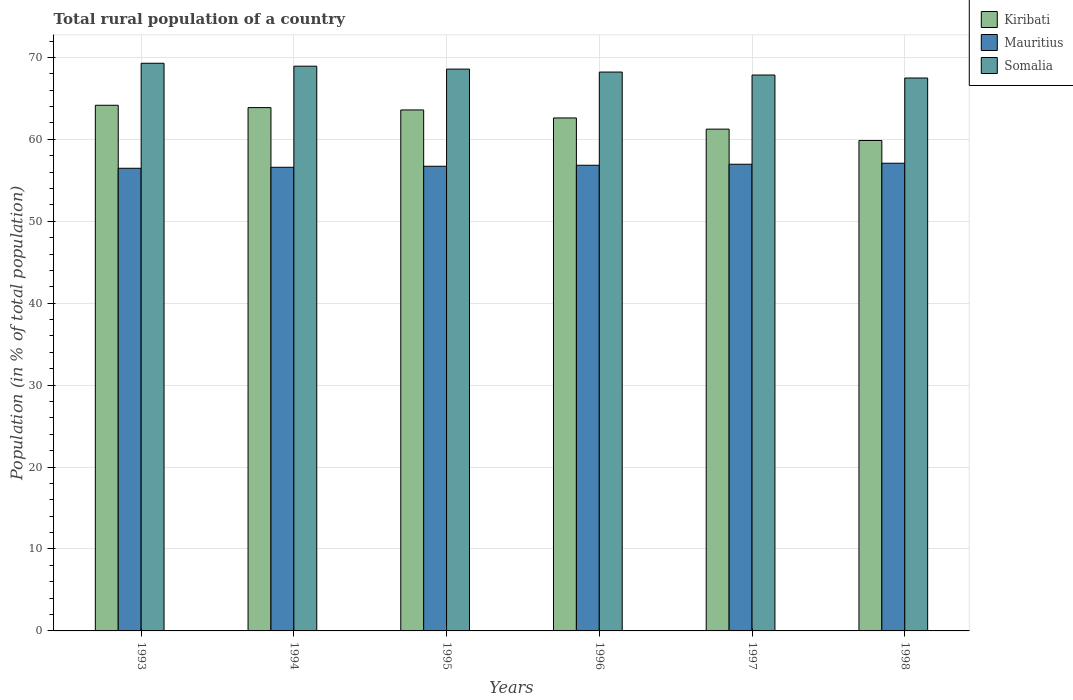How many groups of bars are there?
Provide a succinct answer. 6. Are the number of bars on each tick of the X-axis equal?
Ensure brevity in your answer.  Yes. What is the rural population in Mauritius in 1995?
Your answer should be compact. 56.72. Across all years, what is the maximum rural population in Mauritius?
Provide a short and direct response. 57.08. Across all years, what is the minimum rural population in Somalia?
Ensure brevity in your answer.  67.49. In which year was the rural population in Somalia maximum?
Give a very brief answer. 1993. What is the total rural population in Somalia in the graph?
Your response must be concise. 410.35. What is the difference between the rural population in Mauritius in 1994 and that in 1996?
Your answer should be compact. -0.25. What is the difference between the rural population in Somalia in 1993 and the rural population in Mauritius in 1998?
Offer a very short reply. 12.2. What is the average rural population in Kiribati per year?
Keep it short and to the point. 62.56. In the year 1998, what is the difference between the rural population in Kiribati and rural population in Somalia?
Offer a very short reply. -7.63. What is the ratio of the rural population in Mauritius in 1995 to that in 1997?
Your answer should be compact. 1. Is the rural population in Mauritius in 1993 less than that in 1994?
Offer a terse response. Yes. Is the difference between the rural population in Kiribati in 1994 and 1995 greater than the difference between the rural population in Somalia in 1994 and 1995?
Provide a succinct answer. No. What is the difference between the highest and the second highest rural population in Kiribati?
Your answer should be compact. 0.28. What is the difference between the highest and the lowest rural population in Mauritius?
Offer a very short reply. 0.61. Is the sum of the rural population in Kiribati in 1994 and 1996 greater than the maximum rural population in Somalia across all years?
Ensure brevity in your answer.  Yes. What does the 1st bar from the left in 1993 represents?
Provide a short and direct response. Kiribati. What does the 3rd bar from the right in 1995 represents?
Your response must be concise. Kiribati. Is it the case that in every year, the sum of the rural population in Kiribati and rural population in Somalia is greater than the rural population in Mauritius?
Offer a very short reply. Yes. Are all the bars in the graph horizontal?
Provide a short and direct response. No. How many years are there in the graph?
Ensure brevity in your answer.  6. What is the difference between two consecutive major ticks on the Y-axis?
Provide a succinct answer. 10. Does the graph contain any zero values?
Your answer should be compact. No. Where does the legend appear in the graph?
Ensure brevity in your answer.  Top right. How many legend labels are there?
Offer a terse response. 3. How are the legend labels stacked?
Keep it short and to the point. Vertical. What is the title of the graph?
Your response must be concise. Total rural population of a country. Does "Seychelles" appear as one of the legend labels in the graph?
Your answer should be very brief. No. What is the label or title of the Y-axis?
Provide a succinct answer. Population (in % of total population). What is the Population (in % of total population) of Kiribati in 1993?
Make the answer very short. 64.16. What is the Population (in % of total population) of Mauritius in 1993?
Make the answer very short. 56.47. What is the Population (in % of total population) of Somalia in 1993?
Make the answer very short. 69.29. What is the Population (in % of total population) of Kiribati in 1994?
Keep it short and to the point. 63.88. What is the Population (in % of total population) of Mauritius in 1994?
Make the answer very short. 56.59. What is the Population (in % of total population) of Somalia in 1994?
Provide a succinct answer. 68.93. What is the Population (in % of total population) of Kiribati in 1995?
Ensure brevity in your answer.  63.59. What is the Population (in % of total population) in Mauritius in 1995?
Offer a very short reply. 56.72. What is the Population (in % of total population) in Somalia in 1995?
Your answer should be compact. 68.58. What is the Population (in % of total population) of Kiribati in 1996?
Provide a short and direct response. 62.61. What is the Population (in % of total population) of Mauritius in 1996?
Make the answer very short. 56.84. What is the Population (in % of total population) in Somalia in 1996?
Offer a terse response. 68.22. What is the Population (in % of total population) in Kiribati in 1997?
Your response must be concise. 61.25. What is the Population (in % of total population) of Mauritius in 1997?
Give a very brief answer. 56.96. What is the Population (in % of total population) of Somalia in 1997?
Your answer should be compact. 67.85. What is the Population (in % of total population) of Kiribati in 1998?
Provide a succinct answer. 59.86. What is the Population (in % of total population) in Mauritius in 1998?
Your answer should be compact. 57.08. What is the Population (in % of total population) in Somalia in 1998?
Your response must be concise. 67.49. Across all years, what is the maximum Population (in % of total population) of Kiribati?
Offer a terse response. 64.16. Across all years, what is the maximum Population (in % of total population) of Mauritius?
Your response must be concise. 57.08. Across all years, what is the maximum Population (in % of total population) of Somalia?
Make the answer very short. 69.29. Across all years, what is the minimum Population (in % of total population) in Kiribati?
Keep it short and to the point. 59.86. Across all years, what is the minimum Population (in % of total population) in Mauritius?
Your answer should be very brief. 56.47. Across all years, what is the minimum Population (in % of total population) in Somalia?
Your answer should be very brief. 67.49. What is the total Population (in % of total population) of Kiribati in the graph?
Provide a succinct answer. 375.35. What is the total Population (in % of total population) of Mauritius in the graph?
Provide a succinct answer. 340.66. What is the total Population (in % of total population) in Somalia in the graph?
Offer a terse response. 410.35. What is the difference between the Population (in % of total population) of Kiribati in 1993 and that in 1994?
Ensure brevity in your answer.  0.28. What is the difference between the Population (in % of total population) in Mauritius in 1993 and that in 1994?
Ensure brevity in your answer.  -0.12. What is the difference between the Population (in % of total population) of Somalia in 1993 and that in 1994?
Provide a succinct answer. 0.36. What is the difference between the Population (in % of total population) in Kiribati in 1993 and that in 1995?
Your answer should be very brief. 0.57. What is the difference between the Population (in % of total population) of Mauritius in 1993 and that in 1995?
Offer a very short reply. -0.25. What is the difference between the Population (in % of total population) of Somalia in 1993 and that in 1995?
Make the answer very short. 0.71. What is the difference between the Population (in % of total population) in Kiribati in 1993 and that in 1996?
Ensure brevity in your answer.  1.55. What is the difference between the Population (in % of total population) in Mauritius in 1993 and that in 1996?
Your answer should be very brief. -0.37. What is the difference between the Population (in % of total population) of Somalia in 1993 and that in 1996?
Keep it short and to the point. 1.07. What is the difference between the Population (in % of total population) of Kiribati in 1993 and that in 1997?
Provide a succinct answer. 2.91. What is the difference between the Population (in % of total population) of Mauritius in 1993 and that in 1997?
Provide a succinct answer. -0.49. What is the difference between the Population (in % of total population) in Somalia in 1993 and that in 1997?
Provide a short and direct response. 1.44. What is the difference between the Population (in % of total population) in Kiribati in 1993 and that in 1998?
Ensure brevity in your answer.  4.3. What is the difference between the Population (in % of total population) in Mauritius in 1993 and that in 1998?
Your answer should be compact. -0.61. What is the difference between the Population (in % of total population) in Kiribati in 1994 and that in 1995?
Your response must be concise. 0.29. What is the difference between the Population (in % of total population) in Mauritius in 1994 and that in 1995?
Your answer should be very brief. -0.12. What is the difference between the Population (in % of total population) in Somalia in 1994 and that in 1995?
Make the answer very short. 0.36. What is the difference between the Population (in % of total population) of Kiribati in 1994 and that in 1996?
Give a very brief answer. 1.26. What is the difference between the Population (in % of total population) of Mauritius in 1994 and that in 1996?
Keep it short and to the point. -0.25. What is the difference between the Population (in % of total population) in Somalia in 1994 and that in 1996?
Offer a very short reply. 0.72. What is the difference between the Population (in % of total population) of Kiribati in 1994 and that in 1997?
Your answer should be very brief. 2.63. What is the difference between the Population (in % of total population) in Mauritius in 1994 and that in 1997?
Your response must be concise. -0.37. What is the difference between the Population (in % of total population) in Kiribati in 1994 and that in 1998?
Provide a short and direct response. 4.01. What is the difference between the Population (in % of total population) of Mauritius in 1994 and that in 1998?
Keep it short and to the point. -0.49. What is the difference between the Population (in % of total population) of Somalia in 1994 and that in 1998?
Offer a terse response. 1.44. What is the difference between the Population (in % of total population) of Kiribati in 1995 and that in 1996?
Keep it short and to the point. 0.98. What is the difference between the Population (in % of total population) in Mauritius in 1995 and that in 1996?
Ensure brevity in your answer.  -0.12. What is the difference between the Population (in % of total population) of Somalia in 1995 and that in 1996?
Provide a succinct answer. 0.36. What is the difference between the Population (in % of total population) in Kiribati in 1995 and that in 1997?
Ensure brevity in your answer.  2.34. What is the difference between the Population (in % of total population) of Mauritius in 1995 and that in 1997?
Offer a terse response. -0.25. What is the difference between the Population (in % of total population) of Somalia in 1995 and that in 1997?
Offer a terse response. 0.72. What is the difference between the Population (in % of total population) in Kiribati in 1995 and that in 1998?
Your answer should be compact. 3.73. What is the difference between the Population (in % of total population) of Mauritius in 1995 and that in 1998?
Make the answer very short. -0.37. What is the difference between the Population (in % of total population) of Somalia in 1995 and that in 1998?
Keep it short and to the point. 1.09. What is the difference between the Population (in % of total population) of Kiribati in 1996 and that in 1997?
Your response must be concise. 1.37. What is the difference between the Population (in % of total population) in Mauritius in 1996 and that in 1997?
Offer a terse response. -0.12. What is the difference between the Population (in % of total population) of Somalia in 1996 and that in 1997?
Keep it short and to the point. 0.36. What is the difference between the Population (in % of total population) of Kiribati in 1996 and that in 1998?
Your answer should be compact. 2.75. What is the difference between the Population (in % of total population) of Mauritius in 1996 and that in 1998?
Give a very brief answer. -0.24. What is the difference between the Population (in % of total population) of Somalia in 1996 and that in 1998?
Offer a terse response. 0.73. What is the difference between the Population (in % of total population) of Kiribati in 1997 and that in 1998?
Ensure brevity in your answer.  1.39. What is the difference between the Population (in % of total population) in Mauritius in 1997 and that in 1998?
Give a very brief answer. -0.12. What is the difference between the Population (in % of total population) of Somalia in 1997 and that in 1998?
Make the answer very short. 0.36. What is the difference between the Population (in % of total population) in Kiribati in 1993 and the Population (in % of total population) in Mauritius in 1994?
Your answer should be compact. 7.57. What is the difference between the Population (in % of total population) of Kiribati in 1993 and the Population (in % of total population) of Somalia in 1994?
Offer a very short reply. -4.77. What is the difference between the Population (in % of total population) in Mauritius in 1993 and the Population (in % of total population) in Somalia in 1994?
Keep it short and to the point. -12.46. What is the difference between the Population (in % of total population) in Kiribati in 1993 and the Population (in % of total population) in Mauritius in 1995?
Make the answer very short. 7.45. What is the difference between the Population (in % of total population) in Kiribati in 1993 and the Population (in % of total population) in Somalia in 1995?
Your response must be concise. -4.41. What is the difference between the Population (in % of total population) of Mauritius in 1993 and the Population (in % of total population) of Somalia in 1995?
Offer a very short reply. -12.11. What is the difference between the Population (in % of total population) of Kiribati in 1993 and the Population (in % of total population) of Mauritius in 1996?
Provide a succinct answer. 7.32. What is the difference between the Population (in % of total population) in Kiribati in 1993 and the Population (in % of total population) in Somalia in 1996?
Provide a succinct answer. -4.05. What is the difference between the Population (in % of total population) in Mauritius in 1993 and the Population (in % of total population) in Somalia in 1996?
Provide a short and direct response. -11.74. What is the difference between the Population (in % of total population) of Kiribati in 1993 and the Population (in % of total population) of Mauritius in 1997?
Offer a very short reply. 7.2. What is the difference between the Population (in % of total population) in Kiribati in 1993 and the Population (in % of total population) in Somalia in 1997?
Offer a very short reply. -3.69. What is the difference between the Population (in % of total population) in Mauritius in 1993 and the Population (in % of total population) in Somalia in 1997?
Your answer should be very brief. -11.38. What is the difference between the Population (in % of total population) in Kiribati in 1993 and the Population (in % of total population) in Mauritius in 1998?
Make the answer very short. 7.08. What is the difference between the Population (in % of total population) in Kiribati in 1993 and the Population (in % of total population) in Somalia in 1998?
Offer a very short reply. -3.33. What is the difference between the Population (in % of total population) in Mauritius in 1993 and the Population (in % of total population) in Somalia in 1998?
Offer a very short reply. -11.02. What is the difference between the Population (in % of total population) of Kiribati in 1994 and the Population (in % of total population) of Mauritius in 1995?
Make the answer very short. 7.16. What is the difference between the Population (in % of total population) of Kiribati in 1994 and the Population (in % of total population) of Somalia in 1995?
Offer a terse response. -4.7. What is the difference between the Population (in % of total population) in Mauritius in 1994 and the Population (in % of total population) in Somalia in 1995?
Give a very brief answer. -11.98. What is the difference between the Population (in % of total population) in Kiribati in 1994 and the Population (in % of total population) in Mauritius in 1996?
Provide a succinct answer. 7.04. What is the difference between the Population (in % of total population) of Kiribati in 1994 and the Population (in % of total population) of Somalia in 1996?
Make the answer very short. -4.34. What is the difference between the Population (in % of total population) in Mauritius in 1994 and the Population (in % of total population) in Somalia in 1996?
Provide a short and direct response. -11.62. What is the difference between the Population (in % of total population) in Kiribati in 1994 and the Population (in % of total population) in Mauritius in 1997?
Ensure brevity in your answer.  6.92. What is the difference between the Population (in % of total population) in Kiribati in 1994 and the Population (in % of total population) in Somalia in 1997?
Your answer should be very brief. -3.98. What is the difference between the Population (in % of total population) in Mauritius in 1994 and the Population (in % of total population) in Somalia in 1997?
Ensure brevity in your answer.  -11.26. What is the difference between the Population (in % of total population) of Kiribati in 1994 and the Population (in % of total population) of Mauritius in 1998?
Give a very brief answer. 6.79. What is the difference between the Population (in % of total population) of Kiribati in 1994 and the Population (in % of total population) of Somalia in 1998?
Offer a terse response. -3.61. What is the difference between the Population (in % of total population) of Mauritius in 1994 and the Population (in % of total population) of Somalia in 1998?
Your response must be concise. -10.9. What is the difference between the Population (in % of total population) in Kiribati in 1995 and the Population (in % of total population) in Mauritius in 1996?
Your answer should be compact. 6.75. What is the difference between the Population (in % of total population) in Kiribati in 1995 and the Population (in % of total population) in Somalia in 1996?
Your response must be concise. -4.62. What is the difference between the Population (in % of total population) in Mauritius in 1995 and the Population (in % of total population) in Somalia in 1996?
Provide a succinct answer. -11.5. What is the difference between the Population (in % of total population) in Kiribati in 1995 and the Population (in % of total population) in Mauritius in 1997?
Make the answer very short. 6.63. What is the difference between the Population (in % of total population) in Kiribati in 1995 and the Population (in % of total population) in Somalia in 1997?
Offer a very short reply. -4.26. What is the difference between the Population (in % of total population) of Mauritius in 1995 and the Population (in % of total population) of Somalia in 1997?
Keep it short and to the point. -11.14. What is the difference between the Population (in % of total population) of Kiribati in 1995 and the Population (in % of total population) of Mauritius in 1998?
Your answer should be very brief. 6.51. What is the difference between the Population (in % of total population) in Kiribati in 1995 and the Population (in % of total population) in Somalia in 1998?
Your answer should be very brief. -3.9. What is the difference between the Population (in % of total population) in Mauritius in 1995 and the Population (in % of total population) in Somalia in 1998?
Make the answer very short. -10.77. What is the difference between the Population (in % of total population) of Kiribati in 1996 and the Population (in % of total population) of Mauritius in 1997?
Provide a succinct answer. 5.65. What is the difference between the Population (in % of total population) of Kiribati in 1996 and the Population (in % of total population) of Somalia in 1997?
Provide a succinct answer. -5.24. What is the difference between the Population (in % of total population) of Mauritius in 1996 and the Population (in % of total population) of Somalia in 1997?
Provide a succinct answer. -11.01. What is the difference between the Population (in % of total population) of Kiribati in 1996 and the Population (in % of total population) of Mauritius in 1998?
Make the answer very short. 5.53. What is the difference between the Population (in % of total population) in Kiribati in 1996 and the Population (in % of total population) in Somalia in 1998?
Offer a very short reply. -4.88. What is the difference between the Population (in % of total population) in Mauritius in 1996 and the Population (in % of total population) in Somalia in 1998?
Your answer should be compact. -10.65. What is the difference between the Population (in % of total population) of Kiribati in 1997 and the Population (in % of total population) of Mauritius in 1998?
Provide a short and direct response. 4.16. What is the difference between the Population (in % of total population) of Kiribati in 1997 and the Population (in % of total population) of Somalia in 1998?
Offer a very short reply. -6.24. What is the difference between the Population (in % of total population) of Mauritius in 1997 and the Population (in % of total population) of Somalia in 1998?
Your answer should be very brief. -10.53. What is the average Population (in % of total population) of Kiribati per year?
Make the answer very short. 62.56. What is the average Population (in % of total population) in Mauritius per year?
Ensure brevity in your answer.  56.78. What is the average Population (in % of total population) in Somalia per year?
Ensure brevity in your answer.  68.39. In the year 1993, what is the difference between the Population (in % of total population) of Kiribati and Population (in % of total population) of Mauritius?
Ensure brevity in your answer.  7.69. In the year 1993, what is the difference between the Population (in % of total population) of Kiribati and Population (in % of total population) of Somalia?
Keep it short and to the point. -5.13. In the year 1993, what is the difference between the Population (in % of total population) of Mauritius and Population (in % of total population) of Somalia?
Your answer should be very brief. -12.82. In the year 1994, what is the difference between the Population (in % of total population) in Kiribati and Population (in % of total population) in Mauritius?
Keep it short and to the point. 7.28. In the year 1994, what is the difference between the Population (in % of total population) in Kiribati and Population (in % of total population) in Somalia?
Make the answer very short. -5.06. In the year 1994, what is the difference between the Population (in % of total population) in Mauritius and Population (in % of total population) in Somalia?
Your answer should be very brief. -12.34. In the year 1995, what is the difference between the Population (in % of total population) in Kiribati and Population (in % of total population) in Mauritius?
Offer a very short reply. 6.88. In the year 1995, what is the difference between the Population (in % of total population) in Kiribati and Population (in % of total population) in Somalia?
Offer a terse response. -4.98. In the year 1995, what is the difference between the Population (in % of total population) in Mauritius and Population (in % of total population) in Somalia?
Give a very brief answer. -11.86. In the year 1996, what is the difference between the Population (in % of total population) of Kiribati and Population (in % of total population) of Mauritius?
Your answer should be compact. 5.78. In the year 1996, what is the difference between the Population (in % of total population) in Kiribati and Population (in % of total population) in Somalia?
Make the answer very short. -5.6. In the year 1996, what is the difference between the Population (in % of total population) of Mauritius and Population (in % of total population) of Somalia?
Give a very brief answer. -11.38. In the year 1997, what is the difference between the Population (in % of total population) in Kiribati and Population (in % of total population) in Mauritius?
Offer a terse response. 4.29. In the year 1997, what is the difference between the Population (in % of total population) in Kiribati and Population (in % of total population) in Somalia?
Provide a short and direct response. -6.61. In the year 1997, what is the difference between the Population (in % of total population) of Mauritius and Population (in % of total population) of Somalia?
Offer a very short reply. -10.89. In the year 1998, what is the difference between the Population (in % of total population) in Kiribati and Population (in % of total population) in Mauritius?
Offer a very short reply. 2.78. In the year 1998, what is the difference between the Population (in % of total population) in Kiribati and Population (in % of total population) in Somalia?
Offer a very short reply. -7.63. In the year 1998, what is the difference between the Population (in % of total population) in Mauritius and Population (in % of total population) in Somalia?
Offer a very short reply. -10.4. What is the ratio of the Population (in % of total population) of Mauritius in 1993 to that in 1994?
Offer a very short reply. 1. What is the ratio of the Population (in % of total population) in Kiribati in 1993 to that in 1995?
Ensure brevity in your answer.  1.01. What is the ratio of the Population (in % of total population) of Somalia in 1993 to that in 1995?
Your response must be concise. 1.01. What is the ratio of the Population (in % of total population) in Kiribati in 1993 to that in 1996?
Your answer should be compact. 1.02. What is the ratio of the Population (in % of total population) of Mauritius in 1993 to that in 1996?
Your answer should be very brief. 0.99. What is the ratio of the Population (in % of total population) of Somalia in 1993 to that in 1996?
Provide a short and direct response. 1.02. What is the ratio of the Population (in % of total population) of Kiribati in 1993 to that in 1997?
Ensure brevity in your answer.  1.05. What is the ratio of the Population (in % of total population) of Somalia in 1993 to that in 1997?
Offer a terse response. 1.02. What is the ratio of the Population (in % of total population) in Kiribati in 1993 to that in 1998?
Offer a terse response. 1.07. What is the ratio of the Population (in % of total population) in Somalia in 1993 to that in 1998?
Give a very brief answer. 1.03. What is the ratio of the Population (in % of total population) of Mauritius in 1994 to that in 1995?
Offer a terse response. 1. What is the ratio of the Population (in % of total population) of Somalia in 1994 to that in 1995?
Ensure brevity in your answer.  1.01. What is the ratio of the Population (in % of total population) of Kiribati in 1994 to that in 1996?
Offer a very short reply. 1.02. What is the ratio of the Population (in % of total population) of Somalia in 1994 to that in 1996?
Your answer should be very brief. 1.01. What is the ratio of the Population (in % of total population) of Kiribati in 1994 to that in 1997?
Make the answer very short. 1.04. What is the ratio of the Population (in % of total population) in Mauritius in 1994 to that in 1997?
Provide a succinct answer. 0.99. What is the ratio of the Population (in % of total population) of Somalia in 1994 to that in 1997?
Keep it short and to the point. 1.02. What is the ratio of the Population (in % of total population) in Kiribati in 1994 to that in 1998?
Your answer should be compact. 1.07. What is the ratio of the Population (in % of total population) of Somalia in 1994 to that in 1998?
Your answer should be compact. 1.02. What is the ratio of the Population (in % of total population) in Kiribati in 1995 to that in 1996?
Offer a very short reply. 1.02. What is the ratio of the Population (in % of total population) in Mauritius in 1995 to that in 1996?
Your answer should be compact. 1. What is the ratio of the Population (in % of total population) in Somalia in 1995 to that in 1996?
Provide a succinct answer. 1.01. What is the ratio of the Population (in % of total population) of Kiribati in 1995 to that in 1997?
Your response must be concise. 1.04. What is the ratio of the Population (in % of total population) of Mauritius in 1995 to that in 1997?
Your answer should be very brief. 1. What is the ratio of the Population (in % of total population) in Somalia in 1995 to that in 1997?
Your answer should be very brief. 1.01. What is the ratio of the Population (in % of total population) in Kiribati in 1995 to that in 1998?
Offer a very short reply. 1.06. What is the ratio of the Population (in % of total population) of Somalia in 1995 to that in 1998?
Give a very brief answer. 1.02. What is the ratio of the Population (in % of total population) of Kiribati in 1996 to that in 1997?
Give a very brief answer. 1.02. What is the ratio of the Population (in % of total population) of Kiribati in 1996 to that in 1998?
Your answer should be very brief. 1.05. What is the ratio of the Population (in % of total population) of Somalia in 1996 to that in 1998?
Offer a terse response. 1.01. What is the ratio of the Population (in % of total population) of Kiribati in 1997 to that in 1998?
Provide a short and direct response. 1.02. What is the ratio of the Population (in % of total population) in Mauritius in 1997 to that in 1998?
Provide a short and direct response. 1. What is the ratio of the Population (in % of total population) in Somalia in 1997 to that in 1998?
Your answer should be compact. 1.01. What is the difference between the highest and the second highest Population (in % of total population) of Kiribati?
Keep it short and to the point. 0.28. What is the difference between the highest and the second highest Population (in % of total population) in Mauritius?
Your answer should be compact. 0.12. What is the difference between the highest and the second highest Population (in % of total population) in Somalia?
Provide a succinct answer. 0.36. What is the difference between the highest and the lowest Population (in % of total population) of Kiribati?
Give a very brief answer. 4.3. What is the difference between the highest and the lowest Population (in % of total population) in Mauritius?
Your answer should be compact. 0.61. What is the difference between the highest and the lowest Population (in % of total population) of Somalia?
Offer a very short reply. 1.8. 